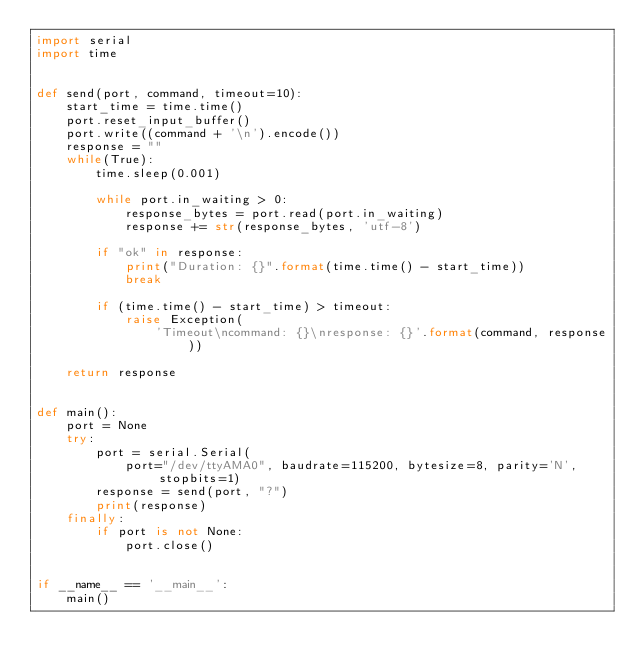<code> <loc_0><loc_0><loc_500><loc_500><_Python_>import serial
import time


def send(port, command, timeout=10):
    start_time = time.time()
    port.reset_input_buffer()
    port.write((command + '\n').encode())
    response = ""
    while(True):
        time.sleep(0.001)

        while port.in_waiting > 0:
            response_bytes = port.read(port.in_waiting)
            response += str(response_bytes, 'utf-8')

        if "ok" in response:
            print("Duration: {}".format(time.time() - start_time))
            break

        if (time.time() - start_time) > timeout:
            raise Exception(
                'Timeout\ncommand: {}\nresponse: {}'.format(command, response))

    return response


def main():
    port = None
    try:
        port = serial.Serial(
            port="/dev/ttyAMA0", baudrate=115200, bytesize=8, parity='N', stopbits=1)
        response = send(port, "?")
        print(response)
    finally:
        if port is not None:
            port.close()


if __name__ == '__main__':
    main()
</code> 